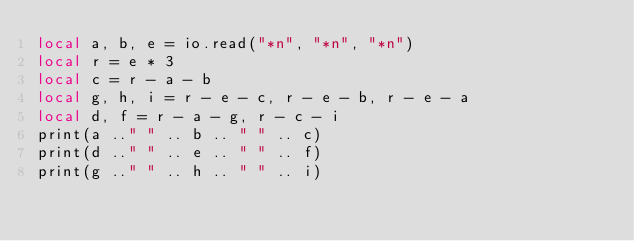Convert code to text. <code><loc_0><loc_0><loc_500><loc_500><_Lua_>local a, b, e = io.read("*n", "*n", "*n")
local r = e * 3
local c = r - a - b
local g, h, i = r - e - c, r - e - b, r - e - a
local d, f = r - a - g, r - c - i
print(a .." " .. b .. " " .. c)
print(d .." " .. e .. " " .. f)
print(g .." " .. h .. " " .. i)
</code> 